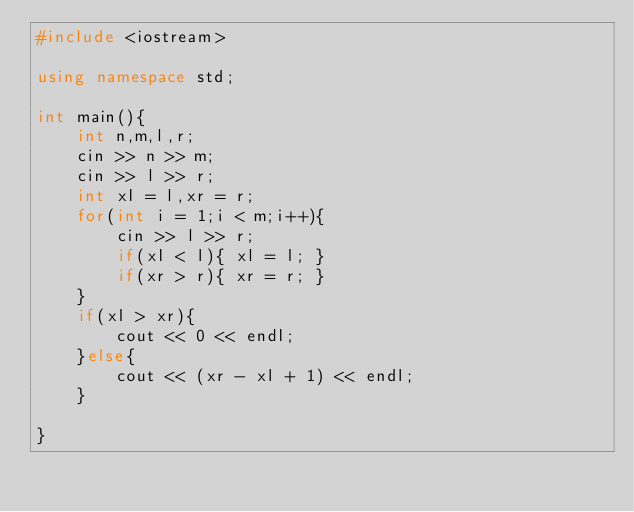Convert code to text. <code><loc_0><loc_0><loc_500><loc_500><_C++_>#include <iostream>

using namespace std;

int main(){
    int n,m,l,r;
    cin >> n >> m;
    cin >> l >> r;
    int xl = l,xr = r;
    for(int i = 1;i < m;i++){
        cin >> l >> r;
        if(xl < l){ xl = l; }
        if(xr > r){ xr = r; }
    }
    if(xl > xr){
        cout << 0 << endl;
    }else{
        cout << (xr - xl + 1) << endl;
    }

}</code> 